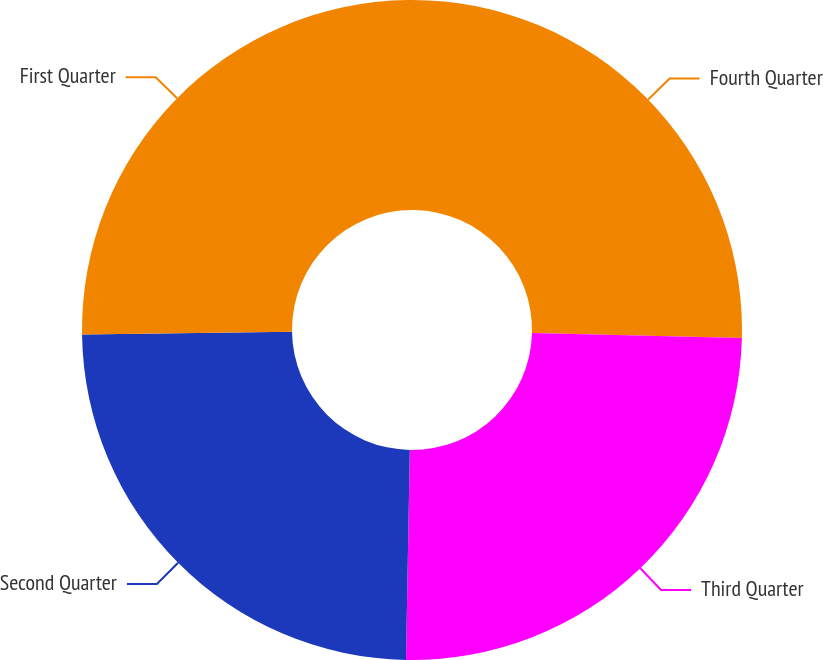Convert chart. <chart><loc_0><loc_0><loc_500><loc_500><pie_chart><fcel>Fourth Quarter<fcel>Third Quarter<fcel>Second Quarter<fcel>First Quarter<nl><fcel>25.39%<fcel>24.9%<fcel>24.49%<fcel>25.22%<nl></chart> 